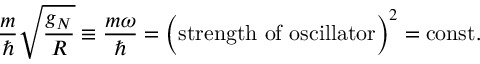<formula> <loc_0><loc_0><loc_500><loc_500>{ \frac { m } { } } \sqrt { \frac { g _ { N } } { R } } \equiv \frac { m \omega } { } = \left ( s t r e n g t h o f o s c i l l a t o r \right ) ^ { 2 } = c o n s t .</formula> 